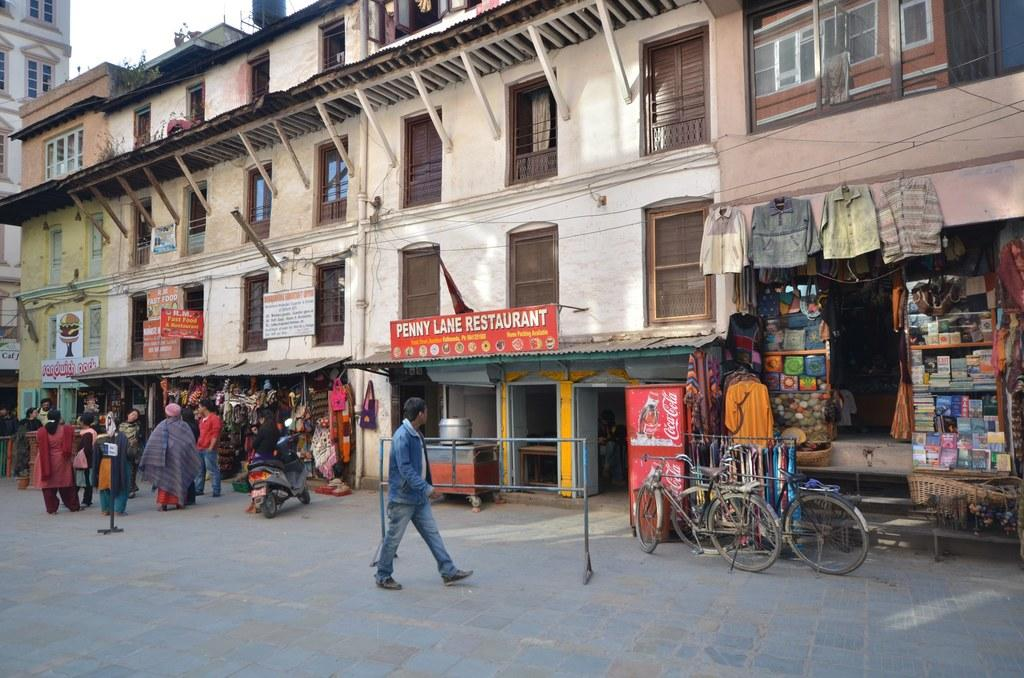<image>
Share a concise interpretation of the image provided. A crowd forms at the shop next door, but only one person passes by the Penny Lane Restaurant. 